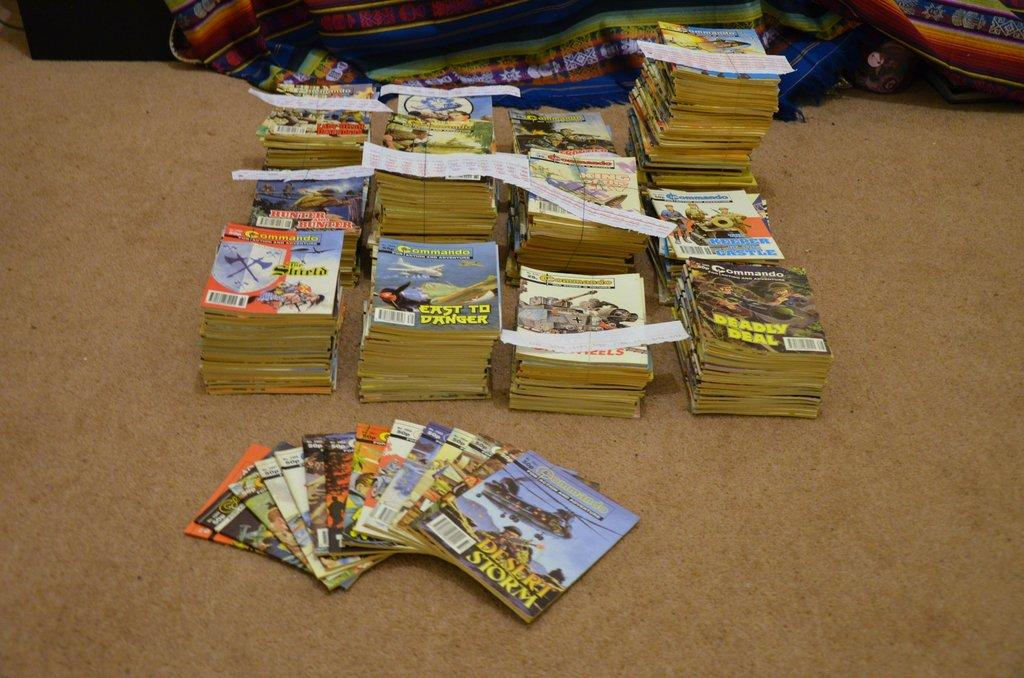What objects are present in the image? There are different types of books in the image. How are the books arranged in the image? The books are kept in a bundle. What direction is the car moving in the image? There is no car present in the image; it only features different types of books kept in a bundle. 